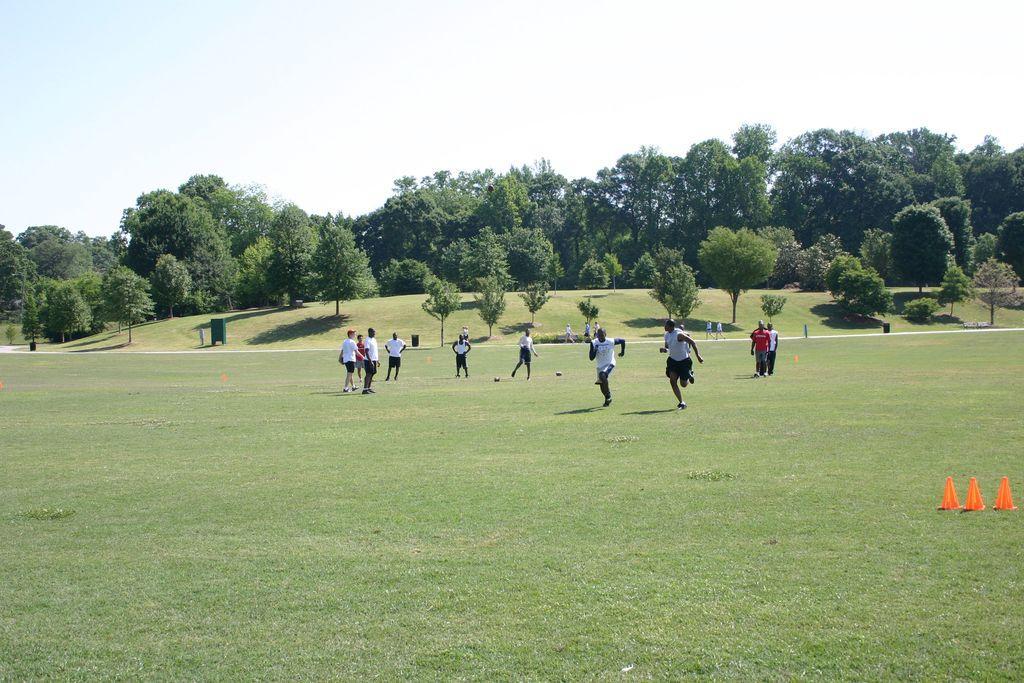Describe this image in one or two sentences. In this image there are people playing on the ground. There are balls on the ground. There is grass on the ground. To the right there are cone barriers on the ground. Behind them there is a road. In the background there are trees on the hill. At the top there is the sky. To the left there is a dustbin on the ground. 